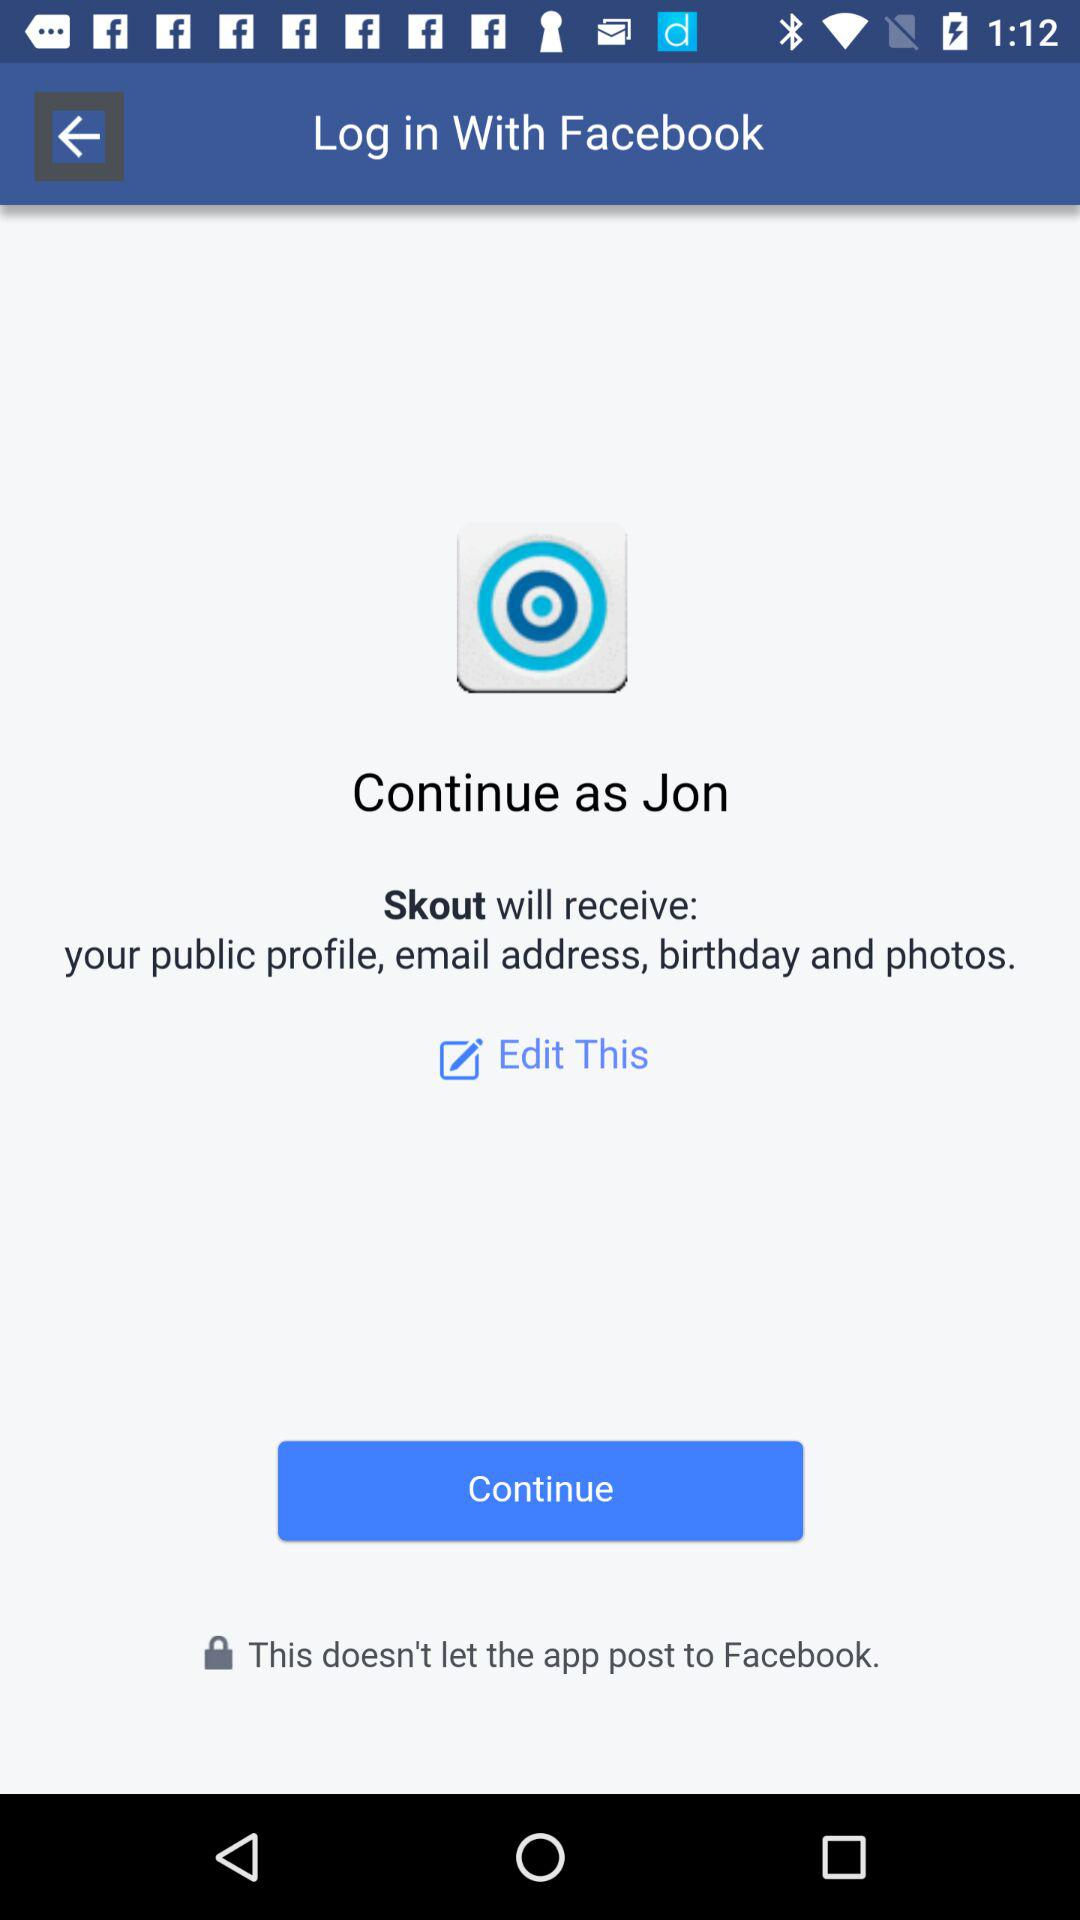What is the name of the user? The name of the user is Jon. 